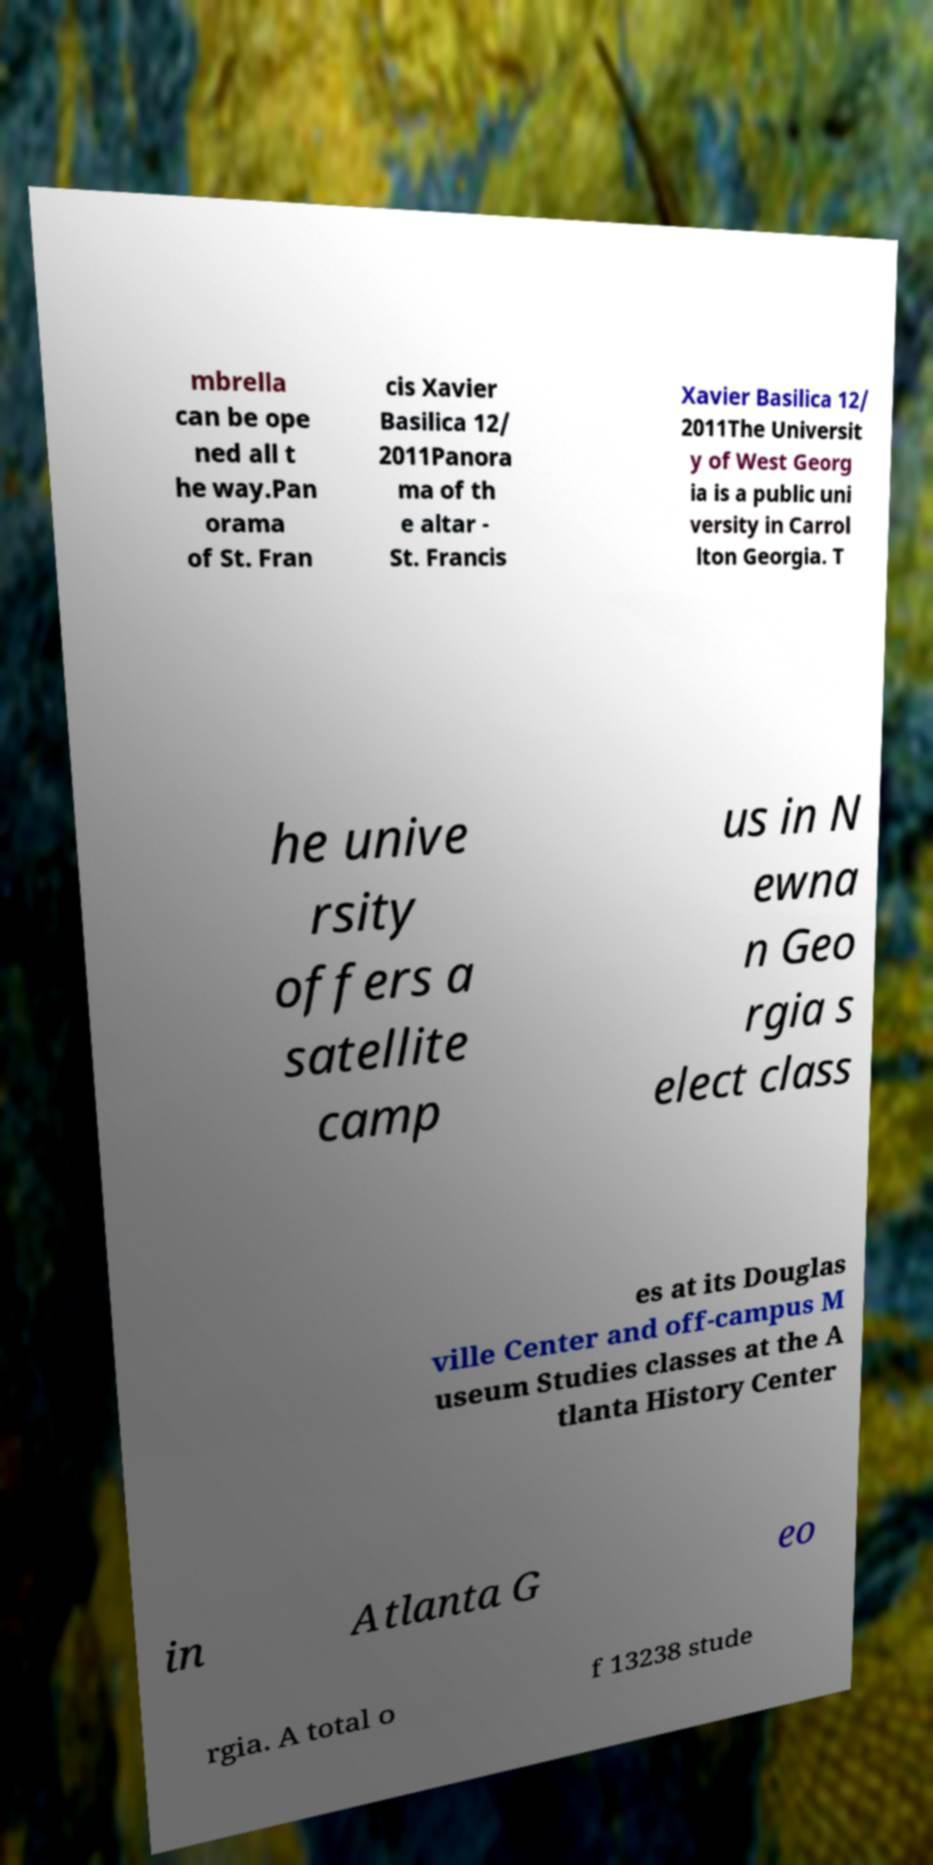Can you accurately transcribe the text from the provided image for me? mbrella can be ope ned all t he way.Pan orama of St. Fran cis Xavier Basilica 12/ 2011Panora ma of th e altar - St. Francis Xavier Basilica 12/ 2011The Universit y of West Georg ia is a public uni versity in Carrol lton Georgia. T he unive rsity offers a satellite camp us in N ewna n Geo rgia s elect class es at its Douglas ville Center and off-campus M useum Studies classes at the A tlanta History Center in Atlanta G eo rgia. A total o f 13238 stude 